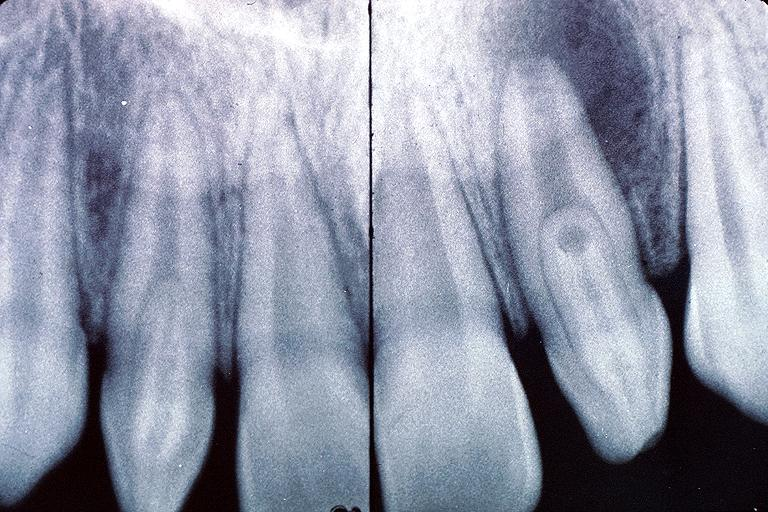s whipples disease present?
Answer the question using a single word or phrase. No 